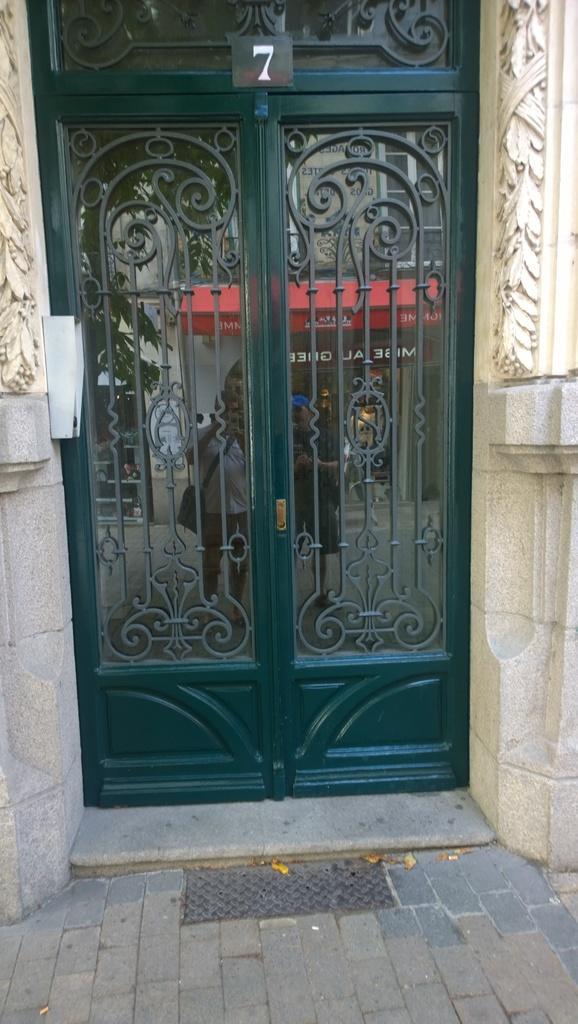In one or two sentences, can you explain what this image depicts? In this picture we can see glass door, walls and board, on this glass door we can see reflection of people standing and we can see boards and leaves. 